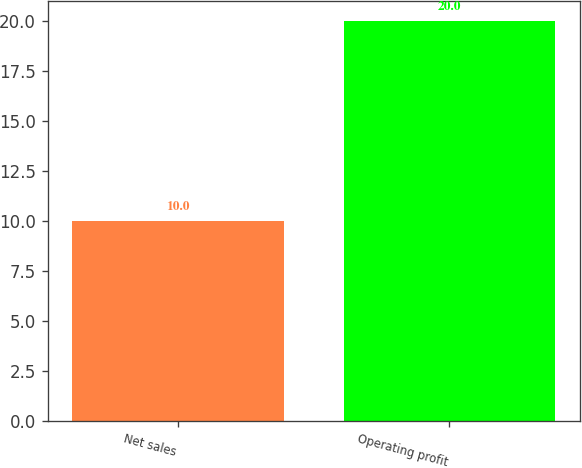Convert chart to OTSL. <chart><loc_0><loc_0><loc_500><loc_500><bar_chart><fcel>Net sales<fcel>Operating profit<nl><fcel>10<fcel>20<nl></chart> 